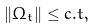<formula> <loc_0><loc_0><loc_500><loc_500>\| \Omega _ { t } \| \leq c . t ,</formula> 